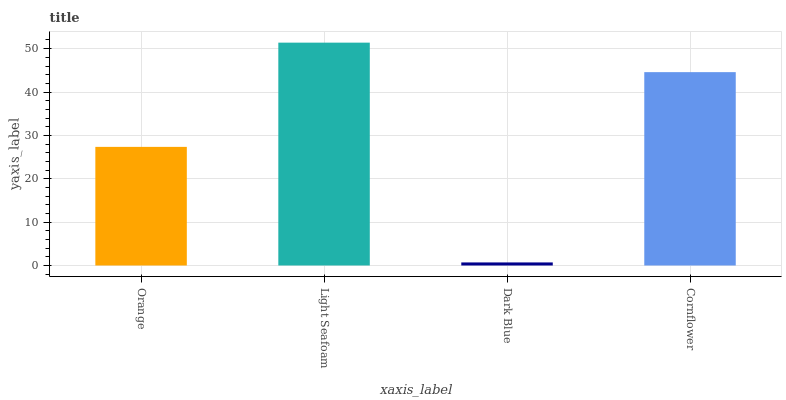Is Dark Blue the minimum?
Answer yes or no. Yes. Is Light Seafoam the maximum?
Answer yes or no. Yes. Is Light Seafoam the minimum?
Answer yes or no. No. Is Dark Blue the maximum?
Answer yes or no. No. Is Light Seafoam greater than Dark Blue?
Answer yes or no. Yes. Is Dark Blue less than Light Seafoam?
Answer yes or no. Yes. Is Dark Blue greater than Light Seafoam?
Answer yes or no. No. Is Light Seafoam less than Dark Blue?
Answer yes or no. No. Is Cornflower the high median?
Answer yes or no. Yes. Is Orange the low median?
Answer yes or no. Yes. Is Dark Blue the high median?
Answer yes or no. No. Is Light Seafoam the low median?
Answer yes or no. No. 